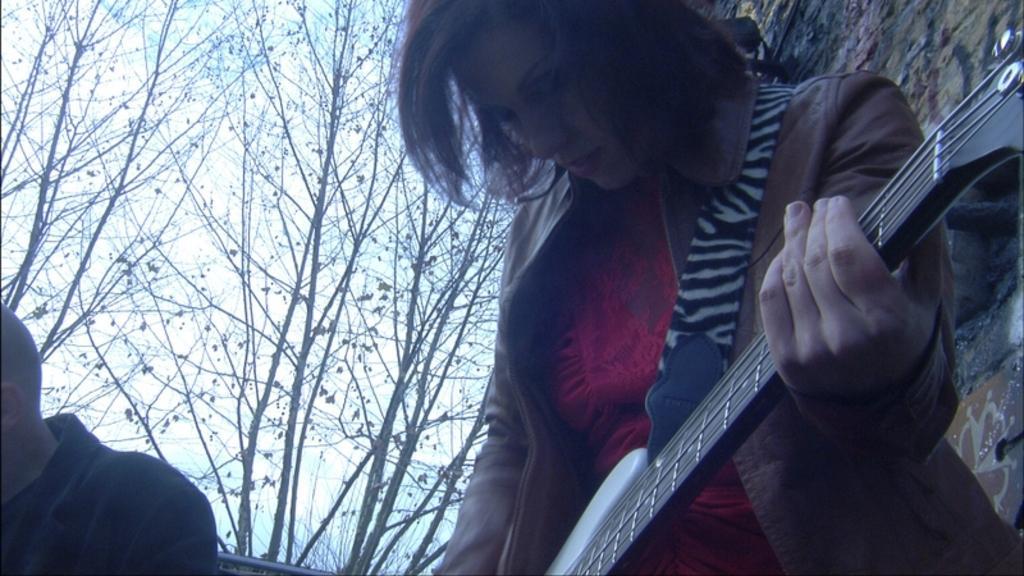Describe this image in one or two sentences. In this image I can see two persons. Among them one person is holding the guitar. And there are some trees and sky in the background. 